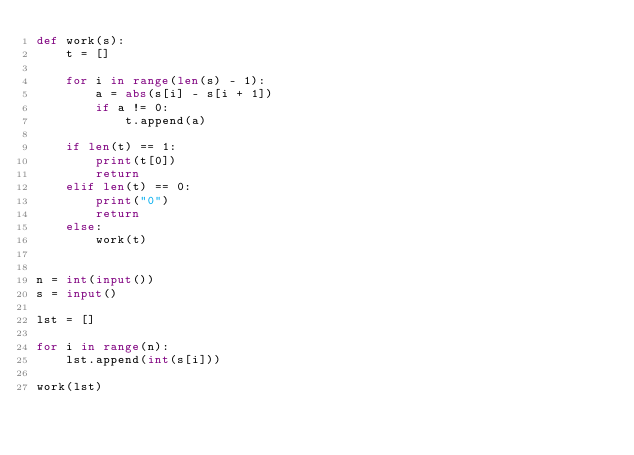Convert code to text. <code><loc_0><loc_0><loc_500><loc_500><_Python_>def work(s):
    t = []

    for i in range(len(s) - 1):
        a = abs(s[i] - s[i + 1])
        if a != 0:
            t.append(a)

    if len(t) == 1:
        print(t[0])
        return
    elif len(t) == 0:
        print("0")
        return
    else:
        work(t)


n = int(input())
s = input()

lst = []

for i in range(n):
    lst.append(int(s[i]))

work(lst)
</code> 